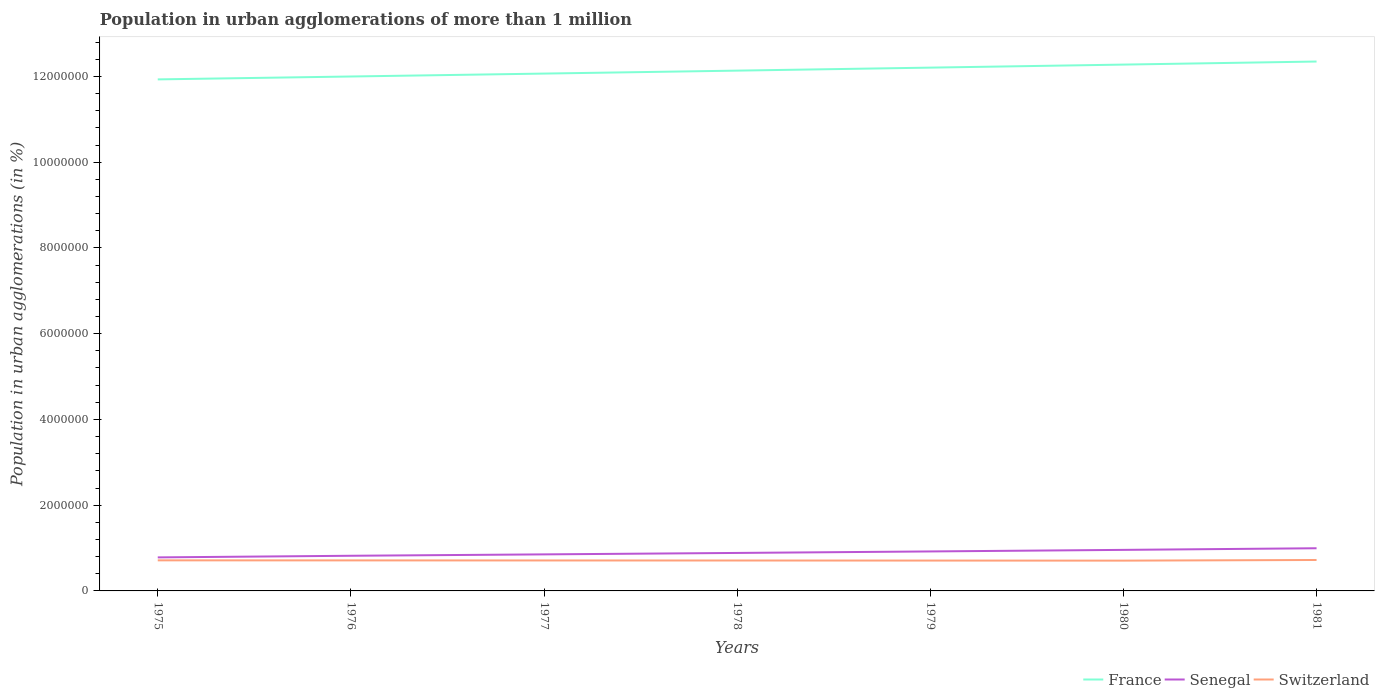How many different coloured lines are there?
Your answer should be compact. 3. Does the line corresponding to France intersect with the line corresponding to Switzerland?
Your response must be concise. No. Across all years, what is the maximum population in urban agglomerations in Senegal?
Your response must be concise. 7.82e+05. In which year was the population in urban agglomerations in France maximum?
Give a very brief answer. 1975. What is the total population in urban agglomerations in France in the graph?
Provide a succinct answer. -6.82e+04. What is the difference between the highest and the second highest population in urban agglomerations in Switzerland?
Offer a terse response. 1.47e+04. What is the difference between the highest and the lowest population in urban agglomerations in France?
Ensure brevity in your answer.  3. How many lines are there?
Offer a very short reply. 3. How many years are there in the graph?
Your answer should be very brief. 7. Does the graph contain any zero values?
Offer a terse response. No. What is the title of the graph?
Keep it short and to the point. Population in urban agglomerations of more than 1 million. Does "Hungary" appear as one of the legend labels in the graph?
Offer a very short reply. No. What is the label or title of the Y-axis?
Provide a short and direct response. Population in urban agglomerations (in %). What is the Population in urban agglomerations (in %) of France in 1975?
Make the answer very short. 1.19e+07. What is the Population in urban agglomerations (in %) in Senegal in 1975?
Provide a short and direct response. 7.82e+05. What is the Population in urban agglomerations (in %) of Switzerland in 1975?
Keep it short and to the point. 7.13e+05. What is the Population in urban agglomerations (in %) of France in 1976?
Your answer should be compact. 1.20e+07. What is the Population in urban agglomerations (in %) in Senegal in 1976?
Ensure brevity in your answer.  8.20e+05. What is the Population in urban agglomerations (in %) in Switzerland in 1976?
Provide a succinct answer. 7.12e+05. What is the Population in urban agglomerations (in %) in France in 1977?
Keep it short and to the point. 1.21e+07. What is the Population in urban agglomerations (in %) in Senegal in 1977?
Give a very brief answer. 8.52e+05. What is the Population in urban agglomerations (in %) in Switzerland in 1977?
Your answer should be very brief. 7.11e+05. What is the Population in urban agglomerations (in %) of France in 1978?
Keep it short and to the point. 1.21e+07. What is the Population in urban agglomerations (in %) in Senegal in 1978?
Your answer should be compact. 8.86e+05. What is the Population in urban agglomerations (in %) in Switzerland in 1978?
Offer a terse response. 7.09e+05. What is the Population in urban agglomerations (in %) in France in 1979?
Provide a succinct answer. 1.22e+07. What is the Population in urban agglomerations (in %) of Senegal in 1979?
Ensure brevity in your answer.  9.21e+05. What is the Population in urban agglomerations (in %) of Switzerland in 1979?
Keep it short and to the point. 7.08e+05. What is the Population in urban agglomerations (in %) of France in 1980?
Give a very brief answer. 1.23e+07. What is the Population in urban agglomerations (in %) in Senegal in 1980?
Keep it short and to the point. 9.57e+05. What is the Population in urban agglomerations (in %) in Switzerland in 1980?
Your response must be concise. 7.07e+05. What is the Population in urban agglomerations (in %) of France in 1981?
Offer a very short reply. 1.23e+07. What is the Population in urban agglomerations (in %) in Senegal in 1981?
Your answer should be compact. 9.95e+05. What is the Population in urban agglomerations (in %) of Switzerland in 1981?
Give a very brief answer. 7.21e+05. Across all years, what is the maximum Population in urban agglomerations (in %) in France?
Your answer should be very brief. 1.23e+07. Across all years, what is the maximum Population in urban agglomerations (in %) of Senegal?
Keep it short and to the point. 9.95e+05. Across all years, what is the maximum Population in urban agglomerations (in %) in Switzerland?
Make the answer very short. 7.21e+05. Across all years, what is the minimum Population in urban agglomerations (in %) in France?
Offer a very short reply. 1.19e+07. Across all years, what is the minimum Population in urban agglomerations (in %) of Senegal?
Your answer should be very brief. 7.82e+05. Across all years, what is the minimum Population in urban agglomerations (in %) of Switzerland?
Offer a terse response. 7.07e+05. What is the total Population in urban agglomerations (in %) of France in the graph?
Your answer should be very brief. 8.50e+07. What is the total Population in urban agglomerations (in %) of Senegal in the graph?
Provide a succinct answer. 6.21e+06. What is the total Population in urban agglomerations (in %) in Switzerland in the graph?
Offer a terse response. 4.98e+06. What is the difference between the Population in urban agglomerations (in %) in France in 1975 and that in 1976?
Your answer should be very brief. -6.76e+04. What is the difference between the Population in urban agglomerations (in %) of Senegal in 1975 and that in 1976?
Make the answer very short. -3.79e+04. What is the difference between the Population in urban agglomerations (in %) of Switzerland in 1975 and that in 1976?
Your answer should be compact. 1311. What is the difference between the Population in urban agglomerations (in %) in France in 1975 and that in 1977?
Provide a succinct answer. -1.36e+05. What is the difference between the Population in urban agglomerations (in %) of Senegal in 1975 and that in 1977?
Provide a short and direct response. -7.03e+04. What is the difference between the Population in urban agglomerations (in %) of Switzerland in 1975 and that in 1977?
Offer a very short reply. 2617. What is the difference between the Population in urban agglomerations (in %) in France in 1975 and that in 1978?
Ensure brevity in your answer.  -2.05e+05. What is the difference between the Population in urban agglomerations (in %) of Senegal in 1975 and that in 1978?
Offer a very short reply. -1.04e+05. What is the difference between the Population in urban agglomerations (in %) in Switzerland in 1975 and that in 1978?
Give a very brief answer. 3922. What is the difference between the Population in urban agglomerations (in %) in France in 1975 and that in 1979?
Your answer should be compact. -2.75e+05. What is the difference between the Population in urban agglomerations (in %) in Senegal in 1975 and that in 1979?
Keep it short and to the point. -1.39e+05. What is the difference between the Population in urban agglomerations (in %) in Switzerland in 1975 and that in 1979?
Provide a short and direct response. 5225. What is the difference between the Population in urban agglomerations (in %) of France in 1975 and that in 1980?
Your response must be concise. -3.45e+05. What is the difference between the Population in urban agglomerations (in %) in Senegal in 1975 and that in 1980?
Ensure brevity in your answer.  -1.75e+05. What is the difference between the Population in urban agglomerations (in %) in Switzerland in 1975 and that in 1980?
Provide a succinct answer. 6527. What is the difference between the Population in urban agglomerations (in %) in France in 1975 and that in 1981?
Give a very brief answer. -4.17e+05. What is the difference between the Population in urban agglomerations (in %) of Senegal in 1975 and that in 1981?
Make the answer very short. -2.13e+05. What is the difference between the Population in urban agglomerations (in %) of Switzerland in 1975 and that in 1981?
Offer a very short reply. -8158. What is the difference between the Population in urban agglomerations (in %) of France in 1976 and that in 1977?
Make the answer very short. -6.82e+04. What is the difference between the Population in urban agglomerations (in %) of Senegal in 1976 and that in 1977?
Give a very brief answer. -3.24e+04. What is the difference between the Population in urban agglomerations (in %) of Switzerland in 1976 and that in 1977?
Provide a short and direct response. 1306. What is the difference between the Population in urban agglomerations (in %) of France in 1976 and that in 1978?
Make the answer very short. -1.37e+05. What is the difference between the Population in urban agglomerations (in %) of Senegal in 1976 and that in 1978?
Provide a succinct answer. -6.60e+04. What is the difference between the Population in urban agglomerations (in %) of Switzerland in 1976 and that in 1978?
Provide a succinct answer. 2611. What is the difference between the Population in urban agglomerations (in %) in France in 1976 and that in 1979?
Ensure brevity in your answer.  -2.07e+05. What is the difference between the Population in urban agglomerations (in %) in Senegal in 1976 and that in 1979?
Offer a terse response. -1.01e+05. What is the difference between the Population in urban agglomerations (in %) in Switzerland in 1976 and that in 1979?
Your answer should be very brief. 3914. What is the difference between the Population in urban agglomerations (in %) of France in 1976 and that in 1980?
Your response must be concise. -2.78e+05. What is the difference between the Population in urban agglomerations (in %) in Senegal in 1976 and that in 1980?
Offer a very short reply. -1.38e+05. What is the difference between the Population in urban agglomerations (in %) of Switzerland in 1976 and that in 1980?
Offer a very short reply. 5216. What is the difference between the Population in urban agglomerations (in %) in France in 1976 and that in 1981?
Your response must be concise. -3.49e+05. What is the difference between the Population in urban agglomerations (in %) in Senegal in 1976 and that in 1981?
Your answer should be compact. -1.75e+05. What is the difference between the Population in urban agglomerations (in %) in Switzerland in 1976 and that in 1981?
Your answer should be compact. -9469. What is the difference between the Population in urban agglomerations (in %) in France in 1977 and that in 1978?
Your answer should be very brief. -6.90e+04. What is the difference between the Population in urban agglomerations (in %) of Senegal in 1977 and that in 1978?
Offer a very short reply. -3.37e+04. What is the difference between the Population in urban agglomerations (in %) of Switzerland in 1977 and that in 1978?
Provide a succinct answer. 1305. What is the difference between the Population in urban agglomerations (in %) in France in 1977 and that in 1979?
Offer a very short reply. -1.39e+05. What is the difference between the Population in urban agglomerations (in %) in Senegal in 1977 and that in 1979?
Ensure brevity in your answer.  -6.87e+04. What is the difference between the Population in urban agglomerations (in %) of Switzerland in 1977 and that in 1979?
Provide a short and direct response. 2608. What is the difference between the Population in urban agglomerations (in %) of France in 1977 and that in 1980?
Provide a short and direct response. -2.10e+05. What is the difference between the Population in urban agglomerations (in %) of Senegal in 1977 and that in 1980?
Offer a terse response. -1.05e+05. What is the difference between the Population in urban agglomerations (in %) of Switzerland in 1977 and that in 1980?
Provide a short and direct response. 3910. What is the difference between the Population in urban agglomerations (in %) of France in 1977 and that in 1981?
Provide a short and direct response. -2.81e+05. What is the difference between the Population in urban agglomerations (in %) in Senegal in 1977 and that in 1981?
Make the answer very short. -1.43e+05. What is the difference between the Population in urban agglomerations (in %) of Switzerland in 1977 and that in 1981?
Your answer should be compact. -1.08e+04. What is the difference between the Population in urban agglomerations (in %) in France in 1978 and that in 1979?
Offer a very short reply. -6.98e+04. What is the difference between the Population in urban agglomerations (in %) of Senegal in 1978 and that in 1979?
Offer a terse response. -3.50e+04. What is the difference between the Population in urban agglomerations (in %) of Switzerland in 1978 and that in 1979?
Offer a very short reply. 1303. What is the difference between the Population in urban agglomerations (in %) of France in 1978 and that in 1980?
Your answer should be very brief. -1.41e+05. What is the difference between the Population in urban agglomerations (in %) in Senegal in 1978 and that in 1980?
Provide a short and direct response. -7.15e+04. What is the difference between the Population in urban agglomerations (in %) in Switzerland in 1978 and that in 1980?
Your answer should be very brief. 2605. What is the difference between the Population in urban agglomerations (in %) in France in 1978 and that in 1981?
Ensure brevity in your answer.  -2.12e+05. What is the difference between the Population in urban agglomerations (in %) of Senegal in 1978 and that in 1981?
Make the answer very short. -1.09e+05. What is the difference between the Population in urban agglomerations (in %) in Switzerland in 1978 and that in 1981?
Offer a very short reply. -1.21e+04. What is the difference between the Population in urban agglomerations (in %) of France in 1979 and that in 1980?
Offer a terse response. -7.08e+04. What is the difference between the Population in urban agglomerations (in %) of Senegal in 1979 and that in 1980?
Your response must be concise. -3.65e+04. What is the difference between the Population in urban agglomerations (in %) in Switzerland in 1979 and that in 1980?
Make the answer very short. 1302. What is the difference between the Population in urban agglomerations (in %) in France in 1979 and that in 1981?
Offer a terse response. -1.42e+05. What is the difference between the Population in urban agglomerations (in %) of Senegal in 1979 and that in 1981?
Provide a short and direct response. -7.42e+04. What is the difference between the Population in urban agglomerations (in %) of Switzerland in 1979 and that in 1981?
Your response must be concise. -1.34e+04. What is the difference between the Population in urban agglomerations (in %) in France in 1980 and that in 1981?
Provide a succinct answer. -7.14e+04. What is the difference between the Population in urban agglomerations (in %) of Senegal in 1980 and that in 1981?
Your answer should be very brief. -3.78e+04. What is the difference between the Population in urban agglomerations (in %) in Switzerland in 1980 and that in 1981?
Offer a terse response. -1.47e+04. What is the difference between the Population in urban agglomerations (in %) of France in 1975 and the Population in urban agglomerations (in %) of Senegal in 1976?
Your response must be concise. 1.11e+07. What is the difference between the Population in urban agglomerations (in %) of France in 1975 and the Population in urban agglomerations (in %) of Switzerland in 1976?
Your answer should be very brief. 1.12e+07. What is the difference between the Population in urban agglomerations (in %) of Senegal in 1975 and the Population in urban agglomerations (in %) of Switzerland in 1976?
Your answer should be very brief. 7.00e+04. What is the difference between the Population in urban agglomerations (in %) in France in 1975 and the Population in urban agglomerations (in %) in Senegal in 1977?
Your response must be concise. 1.11e+07. What is the difference between the Population in urban agglomerations (in %) in France in 1975 and the Population in urban agglomerations (in %) in Switzerland in 1977?
Your answer should be compact. 1.12e+07. What is the difference between the Population in urban agglomerations (in %) of Senegal in 1975 and the Population in urban agglomerations (in %) of Switzerland in 1977?
Provide a short and direct response. 7.13e+04. What is the difference between the Population in urban agglomerations (in %) in France in 1975 and the Population in urban agglomerations (in %) in Senegal in 1978?
Your response must be concise. 1.10e+07. What is the difference between the Population in urban agglomerations (in %) of France in 1975 and the Population in urban agglomerations (in %) of Switzerland in 1978?
Offer a very short reply. 1.12e+07. What is the difference between the Population in urban agglomerations (in %) in Senegal in 1975 and the Population in urban agglomerations (in %) in Switzerland in 1978?
Ensure brevity in your answer.  7.26e+04. What is the difference between the Population in urban agglomerations (in %) in France in 1975 and the Population in urban agglomerations (in %) in Senegal in 1979?
Offer a terse response. 1.10e+07. What is the difference between the Population in urban agglomerations (in %) of France in 1975 and the Population in urban agglomerations (in %) of Switzerland in 1979?
Offer a terse response. 1.12e+07. What is the difference between the Population in urban agglomerations (in %) of Senegal in 1975 and the Population in urban agglomerations (in %) of Switzerland in 1979?
Provide a short and direct response. 7.39e+04. What is the difference between the Population in urban agglomerations (in %) in France in 1975 and the Population in urban agglomerations (in %) in Senegal in 1980?
Keep it short and to the point. 1.10e+07. What is the difference between the Population in urban agglomerations (in %) in France in 1975 and the Population in urban agglomerations (in %) in Switzerland in 1980?
Ensure brevity in your answer.  1.12e+07. What is the difference between the Population in urban agglomerations (in %) in Senegal in 1975 and the Population in urban agglomerations (in %) in Switzerland in 1980?
Keep it short and to the point. 7.52e+04. What is the difference between the Population in urban agglomerations (in %) in France in 1975 and the Population in urban agglomerations (in %) in Senegal in 1981?
Ensure brevity in your answer.  1.09e+07. What is the difference between the Population in urban agglomerations (in %) in France in 1975 and the Population in urban agglomerations (in %) in Switzerland in 1981?
Make the answer very short. 1.12e+07. What is the difference between the Population in urban agglomerations (in %) in Senegal in 1975 and the Population in urban agglomerations (in %) in Switzerland in 1981?
Offer a very short reply. 6.05e+04. What is the difference between the Population in urban agglomerations (in %) in France in 1976 and the Population in urban agglomerations (in %) in Senegal in 1977?
Ensure brevity in your answer.  1.11e+07. What is the difference between the Population in urban agglomerations (in %) in France in 1976 and the Population in urban agglomerations (in %) in Switzerland in 1977?
Your answer should be very brief. 1.13e+07. What is the difference between the Population in urban agglomerations (in %) in Senegal in 1976 and the Population in urban agglomerations (in %) in Switzerland in 1977?
Keep it short and to the point. 1.09e+05. What is the difference between the Population in urban agglomerations (in %) in France in 1976 and the Population in urban agglomerations (in %) in Senegal in 1978?
Ensure brevity in your answer.  1.11e+07. What is the difference between the Population in urban agglomerations (in %) of France in 1976 and the Population in urban agglomerations (in %) of Switzerland in 1978?
Make the answer very short. 1.13e+07. What is the difference between the Population in urban agglomerations (in %) of Senegal in 1976 and the Population in urban agglomerations (in %) of Switzerland in 1978?
Offer a very short reply. 1.11e+05. What is the difference between the Population in urban agglomerations (in %) of France in 1976 and the Population in urban agglomerations (in %) of Senegal in 1979?
Make the answer very short. 1.11e+07. What is the difference between the Population in urban agglomerations (in %) in France in 1976 and the Population in urban agglomerations (in %) in Switzerland in 1979?
Offer a terse response. 1.13e+07. What is the difference between the Population in urban agglomerations (in %) in Senegal in 1976 and the Population in urban agglomerations (in %) in Switzerland in 1979?
Your answer should be compact. 1.12e+05. What is the difference between the Population in urban agglomerations (in %) in France in 1976 and the Population in urban agglomerations (in %) in Senegal in 1980?
Ensure brevity in your answer.  1.10e+07. What is the difference between the Population in urban agglomerations (in %) in France in 1976 and the Population in urban agglomerations (in %) in Switzerland in 1980?
Keep it short and to the point. 1.13e+07. What is the difference between the Population in urban agglomerations (in %) of Senegal in 1976 and the Population in urban agglomerations (in %) of Switzerland in 1980?
Your response must be concise. 1.13e+05. What is the difference between the Population in urban agglomerations (in %) of France in 1976 and the Population in urban agglomerations (in %) of Senegal in 1981?
Offer a terse response. 1.10e+07. What is the difference between the Population in urban agglomerations (in %) of France in 1976 and the Population in urban agglomerations (in %) of Switzerland in 1981?
Provide a short and direct response. 1.13e+07. What is the difference between the Population in urban agglomerations (in %) of Senegal in 1976 and the Population in urban agglomerations (in %) of Switzerland in 1981?
Keep it short and to the point. 9.84e+04. What is the difference between the Population in urban agglomerations (in %) in France in 1977 and the Population in urban agglomerations (in %) in Senegal in 1978?
Your answer should be very brief. 1.12e+07. What is the difference between the Population in urban agglomerations (in %) of France in 1977 and the Population in urban agglomerations (in %) of Switzerland in 1978?
Provide a short and direct response. 1.14e+07. What is the difference between the Population in urban agglomerations (in %) of Senegal in 1977 and the Population in urban agglomerations (in %) of Switzerland in 1978?
Offer a very short reply. 1.43e+05. What is the difference between the Population in urban agglomerations (in %) of France in 1977 and the Population in urban agglomerations (in %) of Senegal in 1979?
Keep it short and to the point. 1.11e+07. What is the difference between the Population in urban agglomerations (in %) in France in 1977 and the Population in urban agglomerations (in %) in Switzerland in 1979?
Ensure brevity in your answer.  1.14e+07. What is the difference between the Population in urban agglomerations (in %) of Senegal in 1977 and the Population in urban agglomerations (in %) of Switzerland in 1979?
Give a very brief answer. 1.44e+05. What is the difference between the Population in urban agglomerations (in %) of France in 1977 and the Population in urban agglomerations (in %) of Senegal in 1980?
Offer a very short reply. 1.11e+07. What is the difference between the Population in urban agglomerations (in %) of France in 1977 and the Population in urban agglomerations (in %) of Switzerland in 1980?
Make the answer very short. 1.14e+07. What is the difference between the Population in urban agglomerations (in %) of Senegal in 1977 and the Population in urban agglomerations (in %) of Switzerland in 1980?
Provide a short and direct response. 1.45e+05. What is the difference between the Population in urban agglomerations (in %) of France in 1977 and the Population in urban agglomerations (in %) of Senegal in 1981?
Your answer should be very brief. 1.11e+07. What is the difference between the Population in urban agglomerations (in %) in France in 1977 and the Population in urban agglomerations (in %) in Switzerland in 1981?
Give a very brief answer. 1.13e+07. What is the difference between the Population in urban agglomerations (in %) of Senegal in 1977 and the Population in urban agglomerations (in %) of Switzerland in 1981?
Provide a succinct answer. 1.31e+05. What is the difference between the Population in urban agglomerations (in %) of France in 1978 and the Population in urban agglomerations (in %) of Senegal in 1979?
Your answer should be compact. 1.12e+07. What is the difference between the Population in urban agglomerations (in %) in France in 1978 and the Population in urban agglomerations (in %) in Switzerland in 1979?
Your answer should be very brief. 1.14e+07. What is the difference between the Population in urban agglomerations (in %) in Senegal in 1978 and the Population in urban agglomerations (in %) in Switzerland in 1979?
Provide a short and direct response. 1.78e+05. What is the difference between the Population in urban agglomerations (in %) of France in 1978 and the Population in urban agglomerations (in %) of Senegal in 1980?
Ensure brevity in your answer.  1.12e+07. What is the difference between the Population in urban agglomerations (in %) in France in 1978 and the Population in urban agglomerations (in %) in Switzerland in 1980?
Keep it short and to the point. 1.14e+07. What is the difference between the Population in urban agglomerations (in %) of Senegal in 1978 and the Population in urban agglomerations (in %) of Switzerland in 1980?
Offer a terse response. 1.79e+05. What is the difference between the Population in urban agglomerations (in %) of France in 1978 and the Population in urban agglomerations (in %) of Senegal in 1981?
Make the answer very short. 1.11e+07. What is the difference between the Population in urban agglomerations (in %) of France in 1978 and the Population in urban agglomerations (in %) of Switzerland in 1981?
Offer a terse response. 1.14e+07. What is the difference between the Population in urban agglomerations (in %) of Senegal in 1978 and the Population in urban agglomerations (in %) of Switzerland in 1981?
Your answer should be very brief. 1.64e+05. What is the difference between the Population in urban agglomerations (in %) of France in 1979 and the Population in urban agglomerations (in %) of Senegal in 1980?
Your response must be concise. 1.12e+07. What is the difference between the Population in urban agglomerations (in %) in France in 1979 and the Population in urban agglomerations (in %) in Switzerland in 1980?
Your response must be concise. 1.15e+07. What is the difference between the Population in urban agglomerations (in %) of Senegal in 1979 and the Population in urban agglomerations (in %) of Switzerland in 1980?
Ensure brevity in your answer.  2.14e+05. What is the difference between the Population in urban agglomerations (in %) in France in 1979 and the Population in urban agglomerations (in %) in Senegal in 1981?
Provide a short and direct response. 1.12e+07. What is the difference between the Population in urban agglomerations (in %) in France in 1979 and the Population in urban agglomerations (in %) in Switzerland in 1981?
Offer a terse response. 1.15e+07. What is the difference between the Population in urban agglomerations (in %) in Senegal in 1979 and the Population in urban agglomerations (in %) in Switzerland in 1981?
Make the answer very short. 2.00e+05. What is the difference between the Population in urban agglomerations (in %) of France in 1980 and the Population in urban agglomerations (in %) of Senegal in 1981?
Your response must be concise. 1.13e+07. What is the difference between the Population in urban agglomerations (in %) of France in 1980 and the Population in urban agglomerations (in %) of Switzerland in 1981?
Your answer should be very brief. 1.16e+07. What is the difference between the Population in urban agglomerations (in %) in Senegal in 1980 and the Population in urban agglomerations (in %) in Switzerland in 1981?
Offer a terse response. 2.36e+05. What is the average Population in urban agglomerations (in %) of France per year?
Offer a very short reply. 1.21e+07. What is the average Population in urban agglomerations (in %) in Senegal per year?
Your answer should be compact. 8.88e+05. What is the average Population in urban agglomerations (in %) in Switzerland per year?
Give a very brief answer. 7.12e+05. In the year 1975, what is the difference between the Population in urban agglomerations (in %) of France and Population in urban agglomerations (in %) of Senegal?
Keep it short and to the point. 1.11e+07. In the year 1975, what is the difference between the Population in urban agglomerations (in %) in France and Population in urban agglomerations (in %) in Switzerland?
Give a very brief answer. 1.12e+07. In the year 1975, what is the difference between the Population in urban agglomerations (in %) in Senegal and Population in urban agglomerations (in %) in Switzerland?
Your response must be concise. 6.87e+04. In the year 1976, what is the difference between the Population in urban agglomerations (in %) in France and Population in urban agglomerations (in %) in Senegal?
Keep it short and to the point. 1.12e+07. In the year 1976, what is the difference between the Population in urban agglomerations (in %) in France and Population in urban agglomerations (in %) in Switzerland?
Offer a terse response. 1.13e+07. In the year 1976, what is the difference between the Population in urban agglomerations (in %) of Senegal and Population in urban agglomerations (in %) of Switzerland?
Give a very brief answer. 1.08e+05. In the year 1977, what is the difference between the Population in urban agglomerations (in %) of France and Population in urban agglomerations (in %) of Senegal?
Make the answer very short. 1.12e+07. In the year 1977, what is the difference between the Population in urban agglomerations (in %) of France and Population in urban agglomerations (in %) of Switzerland?
Offer a terse response. 1.14e+07. In the year 1977, what is the difference between the Population in urban agglomerations (in %) of Senegal and Population in urban agglomerations (in %) of Switzerland?
Make the answer very short. 1.42e+05. In the year 1978, what is the difference between the Population in urban agglomerations (in %) in France and Population in urban agglomerations (in %) in Senegal?
Ensure brevity in your answer.  1.12e+07. In the year 1978, what is the difference between the Population in urban agglomerations (in %) of France and Population in urban agglomerations (in %) of Switzerland?
Give a very brief answer. 1.14e+07. In the year 1978, what is the difference between the Population in urban agglomerations (in %) in Senegal and Population in urban agglomerations (in %) in Switzerland?
Make the answer very short. 1.77e+05. In the year 1979, what is the difference between the Population in urban agglomerations (in %) of France and Population in urban agglomerations (in %) of Senegal?
Offer a very short reply. 1.13e+07. In the year 1979, what is the difference between the Population in urban agglomerations (in %) of France and Population in urban agglomerations (in %) of Switzerland?
Provide a succinct answer. 1.15e+07. In the year 1979, what is the difference between the Population in urban agglomerations (in %) of Senegal and Population in urban agglomerations (in %) of Switzerland?
Your answer should be compact. 2.13e+05. In the year 1980, what is the difference between the Population in urban agglomerations (in %) in France and Population in urban agglomerations (in %) in Senegal?
Your response must be concise. 1.13e+07. In the year 1980, what is the difference between the Population in urban agglomerations (in %) in France and Population in urban agglomerations (in %) in Switzerland?
Your answer should be compact. 1.16e+07. In the year 1980, what is the difference between the Population in urban agglomerations (in %) in Senegal and Population in urban agglomerations (in %) in Switzerland?
Offer a very short reply. 2.51e+05. In the year 1981, what is the difference between the Population in urban agglomerations (in %) of France and Population in urban agglomerations (in %) of Senegal?
Your answer should be very brief. 1.14e+07. In the year 1981, what is the difference between the Population in urban agglomerations (in %) of France and Population in urban agglomerations (in %) of Switzerland?
Offer a terse response. 1.16e+07. In the year 1981, what is the difference between the Population in urban agglomerations (in %) of Senegal and Population in urban agglomerations (in %) of Switzerland?
Ensure brevity in your answer.  2.74e+05. What is the ratio of the Population in urban agglomerations (in %) of Senegal in 1975 to that in 1976?
Your response must be concise. 0.95. What is the ratio of the Population in urban agglomerations (in %) of Switzerland in 1975 to that in 1976?
Give a very brief answer. 1. What is the ratio of the Population in urban agglomerations (in %) of Senegal in 1975 to that in 1977?
Make the answer very short. 0.92. What is the ratio of the Population in urban agglomerations (in %) of Switzerland in 1975 to that in 1977?
Give a very brief answer. 1. What is the ratio of the Population in urban agglomerations (in %) in France in 1975 to that in 1978?
Make the answer very short. 0.98. What is the ratio of the Population in urban agglomerations (in %) in Senegal in 1975 to that in 1978?
Your answer should be very brief. 0.88. What is the ratio of the Population in urban agglomerations (in %) of Switzerland in 1975 to that in 1978?
Your response must be concise. 1.01. What is the ratio of the Population in urban agglomerations (in %) of France in 1975 to that in 1979?
Give a very brief answer. 0.98. What is the ratio of the Population in urban agglomerations (in %) in Senegal in 1975 to that in 1979?
Ensure brevity in your answer.  0.85. What is the ratio of the Population in urban agglomerations (in %) of Switzerland in 1975 to that in 1979?
Ensure brevity in your answer.  1.01. What is the ratio of the Population in urban agglomerations (in %) of France in 1975 to that in 1980?
Ensure brevity in your answer.  0.97. What is the ratio of the Population in urban agglomerations (in %) of Senegal in 1975 to that in 1980?
Your answer should be very brief. 0.82. What is the ratio of the Population in urban agglomerations (in %) in Switzerland in 1975 to that in 1980?
Keep it short and to the point. 1.01. What is the ratio of the Population in urban agglomerations (in %) of France in 1975 to that in 1981?
Offer a terse response. 0.97. What is the ratio of the Population in urban agglomerations (in %) in Senegal in 1975 to that in 1981?
Offer a terse response. 0.79. What is the ratio of the Population in urban agglomerations (in %) in Switzerland in 1975 to that in 1981?
Keep it short and to the point. 0.99. What is the ratio of the Population in urban agglomerations (in %) in Switzerland in 1976 to that in 1977?
Offer a terse response. 1. What is the ratio of the Population in urban agglomerations (in %) of France in 1976 to that in 1978?
Your response must be concise. 0.99. What is the ratio of the Population in urban agglomerations (in %) of Senegal in 1976 to that in 1978?
Keep it short and to the point. 0.93. What is the ratio of the Population in urban agglomerations (in %) of Switzerland in 1976 to that in 1978?
Give a very brief answer. 1. What is the ratio of the Population in urban agglomerations (in %) in France in 1976 to that in 1979?
Offer a terse response. 0.98. What is the ratio of the Population in urban agglomerations (in %) in Senegal in 1976 to that in 1979?
Provide a succinct answer. 0.89. What is the ratio of the Population in urban agglomerations (in %) in Switzerland in 1976 to that in 1979?
Make the answer very short. 1.01. What is the ratio of the Population in urban agglomerations (in %) of France in 1976 to that in 1980?
Offer a very short reply. 0.98. What is the ratio of the Population in urban agglomerations (in %) in Senegal in 1976 to that in 1980?
Give a very brief answer. 0.86. What is the ratio of the Population in urban agglomerations (in %) in Switzerland in 1976 to that in 1980?
Ensure brevity in your answer.  1.01. What is the ratio of the Population in urban agglomerations (in %) in France in 1976 to that in 1981?
Keep it short and to the point. 0.97. What is the ratio of the Population in urban agglomerations (in %) in Senegal in 1976 to that in 1981?
Offer a terse response. 0.82. What is the ratio of the Population in urban agglomerations (in %) of Switzerland in 1976 to that in 1981?
Offer a terse response. 0.99. What is the ratio of the Population in urban agglomerations (in %) of France in 1977 to that in 1978?
Your answer should be compact. 0.99. What is the ratio of the Population in urban agglomerations (in %) of Senegal in 1977 to that in 1978?
Make the answer very short. 0.96. What is the ratio of the Population in urban agglomerations (in %) of Switzerland in 1977 to that in 1978?
Your response must be concise. 1. What is the ratio of the Population in urban agglomerations (in %) in France in 1977 to that in 1979?
Offer a very short reply. 0.99. What is the ratio of the Population in urban agglomerations (in %) of Senegal in 1977 to that in 1979?
Provide a succinct answer. 0.93. What is the ratio of the Population in urban agglomerations (in %) in Switzerland in 1977 to that in 1979?
Your response must be concise. 1. What is the ratio of the Population in urban agglomerations (in %) in France in 1977 to that in 1980?
Give a very brief answer. 0.98. What is the ratio of the Population in urban agglomerations (in %) of Senegal in 1977 to that in 1980?
Your response must be concise. 0.89. What is the ratio of the Population in urban agglomerations (in %) of France in 1977 to that in 1981?
Your response must be concise. 0.98. What is the ratio of the Population in urban agglomerations (in %) of Senegal in 1977 to that in 1981?
Give a very brief answer. 0.86. What is the ratio of the Population in urban agglomerations (in %) in Switzerland in 1977 to that in 1981?
Provide a succinct answer. 0.99. What is the ratio of the Population in urban agglomerations (in %) of Senegal in 1978 to that in 1979?
Give a very brief answer. 0.96. What is the ratio of the Population in urban agglomerations (in %) in France in 1978 to that in 1980?
Make the answer very short. 0.99. What is the ratio of the Population in urban agglomerations (in %) in Senegal in 1978 to that in 1980?
Offer a terse response. 0.93. What is the ratio of the Population in urban agglomerations (in %) of Switzerland in 1978 to that in 1980?
Your response must be concise. 1. What is the ratio of the Population in urban agglomerations (in %) in France in 1978 to that in 1981?
Give a very brief answer. 0.98. What is the ratio of the Population in urban agglomerations (in %) of Senegal in 1978 to that in 1981?
Your answer should be compact. 0.89. What is the ratio of the Population in urban agglomerations (in %) of Switzerland in 1978 to that in 1981?
Offer a very short reply. 0.98. What is the ratio of the Population in urban agglomerations (in %) of Senegal in 1979 to that in 1980?
Provide a short and direct response. 0.96. What is the ratio of the Population in urban agglomerations (in %) in Switzerland in 1979 to that in 1980?
Offer a very short reply. 1. What is the ratio of the Population in urban agglomerations (in %) in France in 1979 to that in 1981?
Offer a very short reply. 0.99. What is the ratio of the Population in urban agglomerations (in %) of Senegal in 1979 to that in 1981?
Provide a succinct answer. 0.93. What is the ratio of the Population in urban agglomerations (in %) in Switzerland in 1979 to that in 1981?
Make the answer very short. 0.98. What is the ratio of the Population in urban agglomerations (in %) in Switzerland in 1980 to that in 1981?
Keep it short and to the point. 0.98. What is the difference between the highest and the second highest Population in urban agglomerations (in %) in France?
Make the answer very short. 7.14e+04. What is the difference between the highest and the second highest Population in urban agglomerations (in %) of Senegal?
Your response must be concise. 3.78e+04. What is the difference between the highest and the second highest Population in urban agglomerations (in %) in Switzerland?
Offer a terse response. 8158. What is the difference between the highest and the lowest Population in urban agglomerations (in %) of France?
Give a very brief answer. 4.17e+05. What is the difference between the highest and the lowest Population in urban agglomerations (in %) of Senegal?
Offer a very short reply. 2.13e+05. What is the difference between the highest and the lowest Population in urban agglomerations (in %) of Switzerland?
Provide a succinct answer. 1.47e+04. 